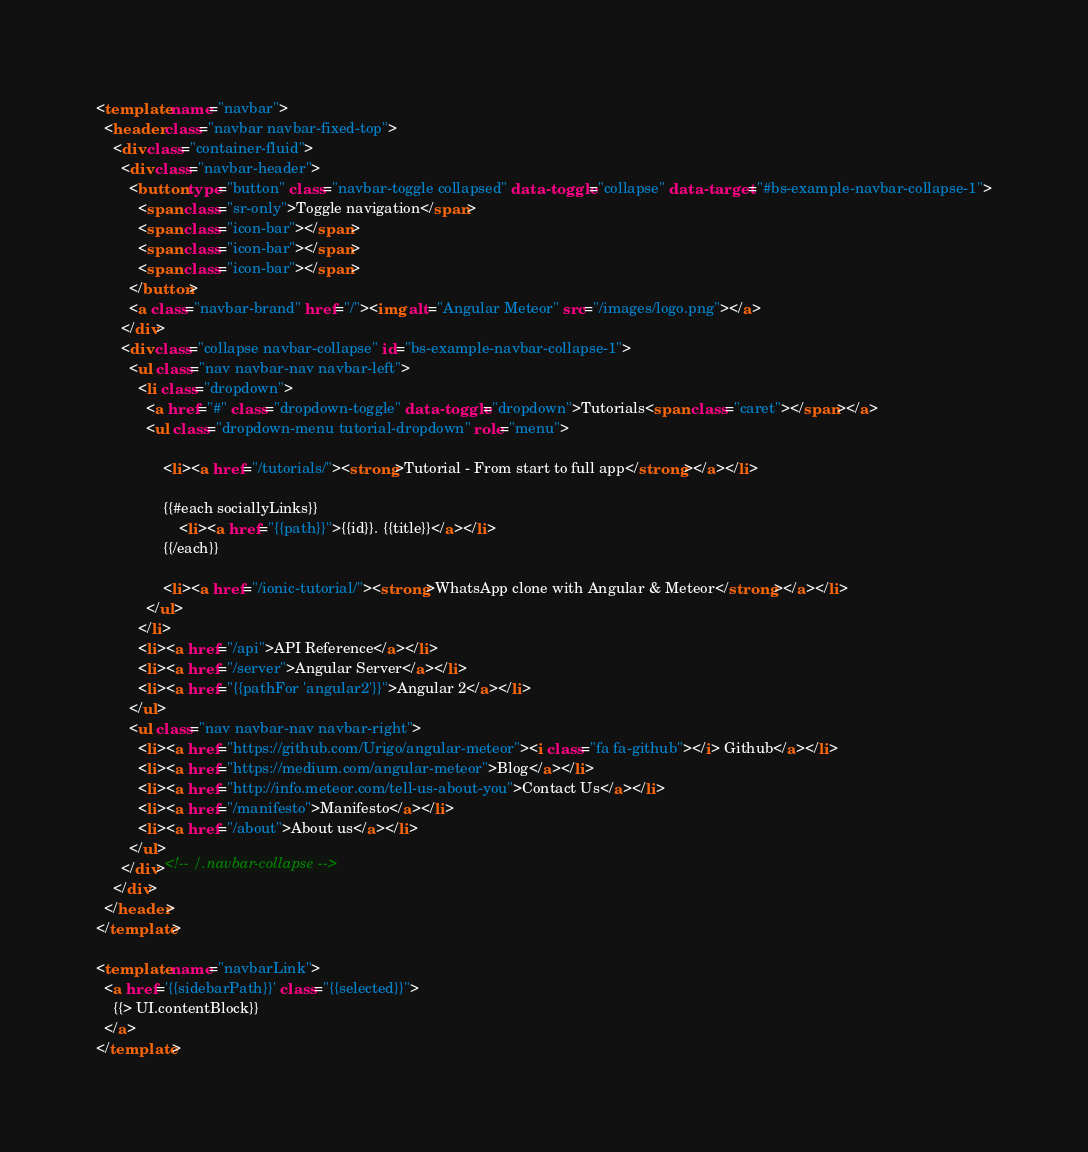Convert code to text. <code><loc_0><loc_0><loc_500><loc_500><_HTML_><template name="navbar">
  <header class="navbar navbar-fixed-top">
    <div class="container-fluid">
      <div class="navbar-header">
        <button type="button" class="navbar-toggle collapsed" data-toggle="collapse" data-target="#bs-example-navbar-collapse-1">
          <span class="sr-only">Toggle navigation</span>
          <span class="icon-bar"></span>
          <span class="icon-bar"></span>
          <span class="icon-bar"></span>
        </button>
        <a class="navbar-brand" href="/"><img alt="Angular Meteor" src="/images/logo.png"></a>
      </div>
      <div class="collapse navbar-collapse" id="bs-example-navbar-collapse-1">
        <ul class="nav navbar-nav navbar-left">
          <li class="dropdown">
            <a href="#" class="dropdown-toggle" data-toggle="dropdown">Tutorials<span class="caret"></span></a>
            <ul class="dropdown-menu tutorial-dropdown" role="menu">

                <li><a href="/tutorials/"><strong>Tutorial - From start to full app</strong></a></li>

                {{#each sociallyLinks}}
                    <li><a href="{{path}}">{{id}}. {{title}}</a></li>
                {{/each}}

                <li><a href="/ionic-tutorial/"><strong>WhatsApp clone with Angular & Meteor</strong></a></li>
            </ul>
          </li>
          <li><a href="/api">API Reference</a></li>
          <li><a href="/server">Angular Server</a></li>
          <li><a href="{{pathFor 'angular2'}}">Angular 2</a></li>
        </ul>
        <ul class="nav navbar-nav navbar-right">
          <li><a href="https://github.com/Urigo/angular-meteor"><i class="fa fa-github"></i> Github</a></li>
          <li><a href="https://medium.com/angular-meteor">Blog</a></li>
          <li><a href="http://info.meteor.com/tell-us-about-you">Contact Us</a></li>
          <li><a href="/manifesto">Manifesto</a></li>
          <li><a href="/about">About us</a></li>
        </ul>
      </div><!-- /.navbar-collapse -->
    </div>
  </header>
</template>

<template name="navbarLink">
  <a href='{{sidebarPath}}' class="{{selected}}">
    {{> UI.contentBlock}}
  </a>
</template>
</code> 